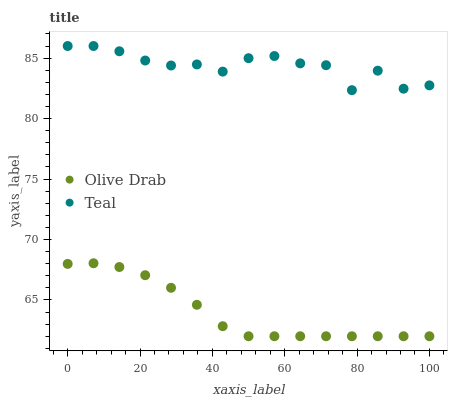Does Olive Drab have the minimum area under the curve?
Answer yes or no. Yes. Does Teal have the maximum area under the curve?
Answer yes or no. Yes. Does Olive Drab have the maximum area under the curve?
Answer yes or no. No. Is Olive Drab the smoothest?
Answer yes or no. Yes. Is Teal the roughest?
Answer yes or no. Yes. Is Olive Drab the roughest?
Answer yes or no. No. Does Olive Drab have the lowest value?
Answer yes or no. Yes. Does Teal have the highest value?
Answer yes or no. Yes. Does Olive Drab have the highest value?
Answer yes or no. No. Is Olive Drab less than Teal?
Answer yes or no. Yes. Is Teal greater than Olive Drab?
Answer yes or no. Yes. Does Olive Drab intersect Teal?
Answer yes or no. No. 